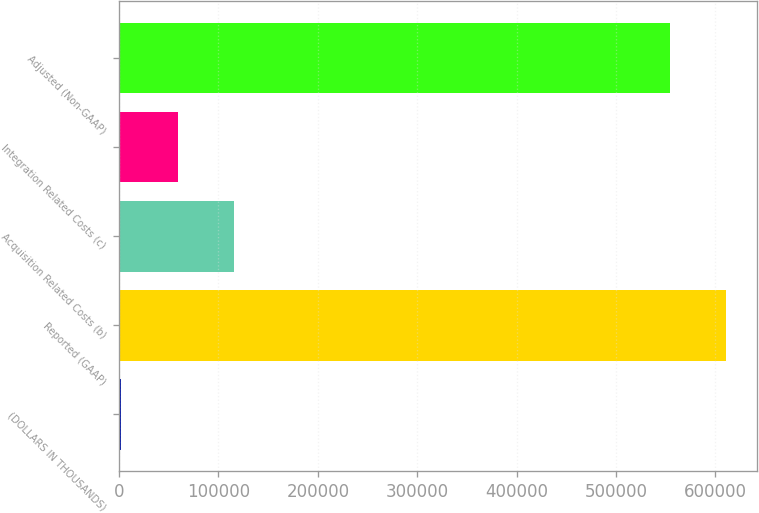<chart> <loc_0><loc_0><loc_500><loc_500><bar_chart><fcel>(DOLLARS IN THOUSANDS)<fcel>Reported (GAAP)<fcel>Acquisition Related Costs (b)<fcel>Integration Related Costs (c)<fcel>Adjusted (Non-GAAP)<nl><fcel>2017<fcel>610957<fcel>115642<fcel>58829.7<fcel>554144<nl></chart> 